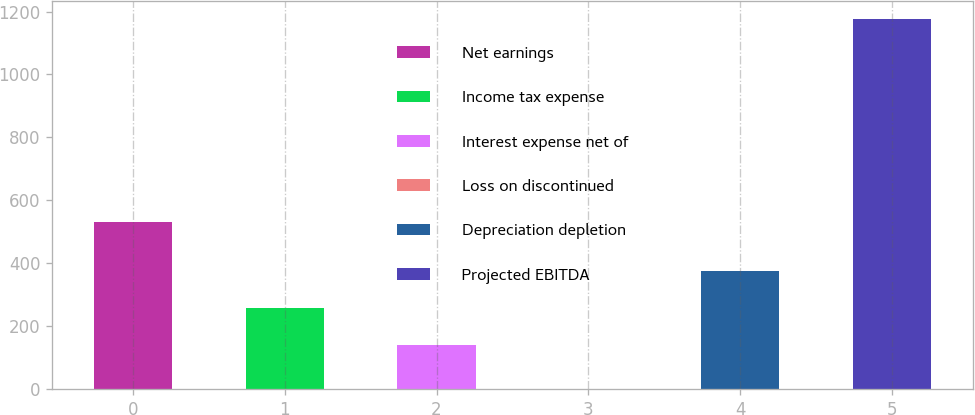Convert chart. <chart><loc_0><loc_0><loc_500><loc_500><bar_chart><fcel>Net earnings<fcel>Income tax expense<fcel>Interest expense net of<fcel>Loss on discontinued<fcel>Depreciation depletion<fcel>Projected EBITDA<nl><fcel>530<fcel>257.38<fcel>140<fcel>1.24<fcel>374.76<fcel>1175<nl></chart> 